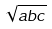<formula> <loc_0><loc_0><loc_500><loc_500>\sqrt { a b c }</formula> 